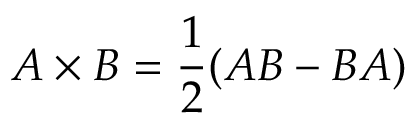Convert formula to latex. <formula><loc_0><loc_0><loc_500><loc_500>A \times B = { \frac { 1 } { 2 } } ( A B - B A )</formula> 